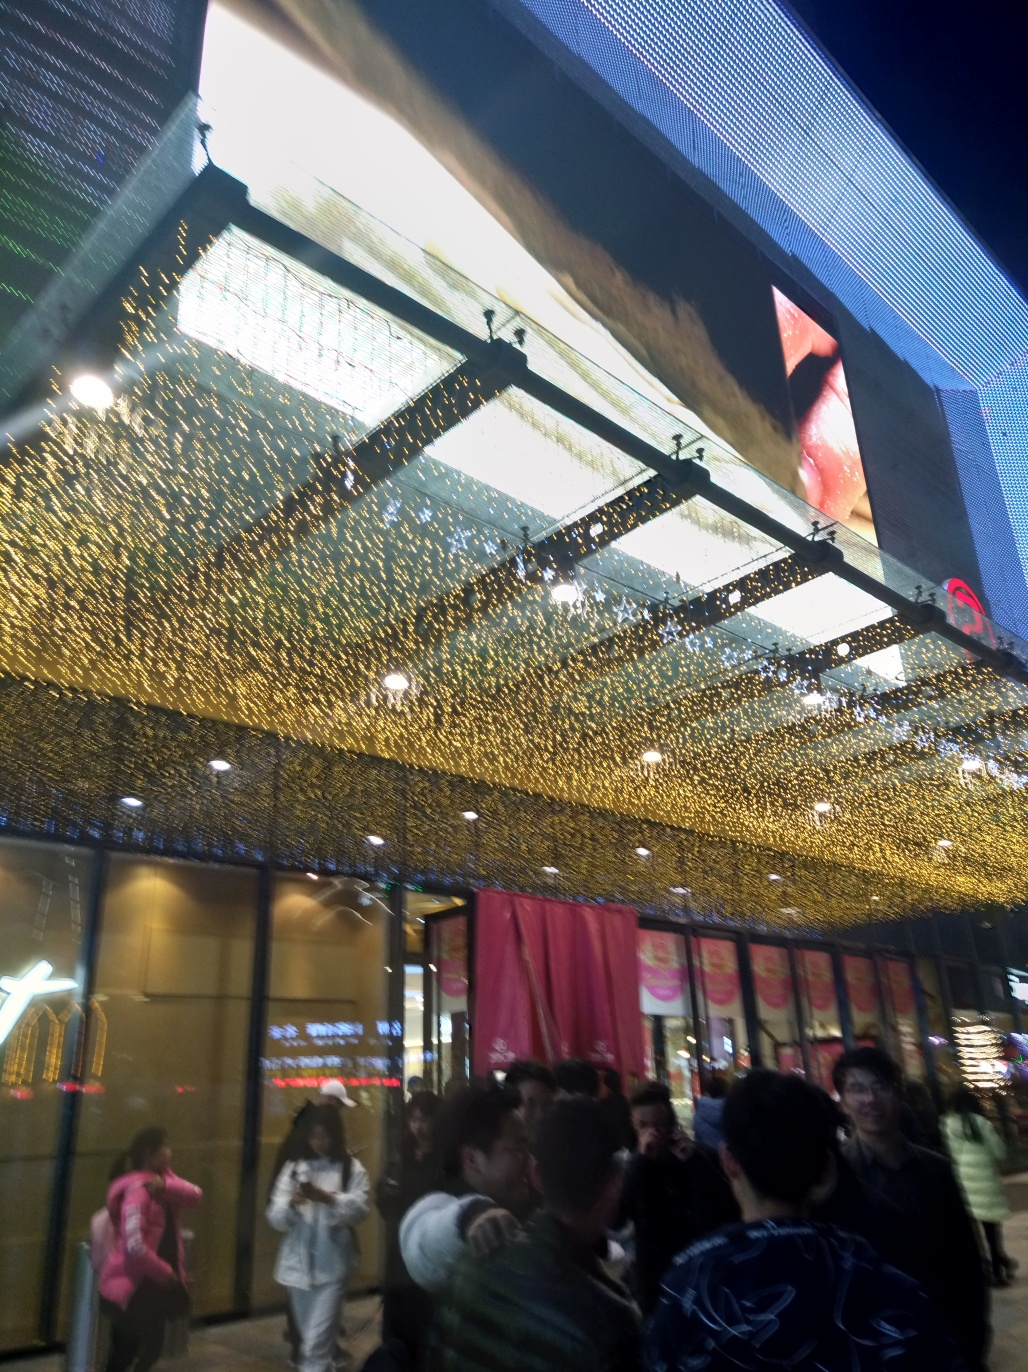Can you describe the lighting in this image? The image showcases an intriguing interplay of lighting. There's a warm, golden light flooding from the ceiling, possibly a decorative light installation, which contrasts with the cooler and harsher artificial lights from signs and building interiors. This varied lighting creates a festive or celebratory atmosphere, drawing attention to the building. What can you infer about the location from this image? This image appears to capture a bustling urban scene at night. Given the presence of what looks like signage in a non-Latin script and the style of clothing worn by individuals, it might be somewhere in East Asia. The large crowd and the upscale atmosphere suggested by the gold-toned shopfront indicate that this could be a shopping district or a commercial area that stays active into the evening. 